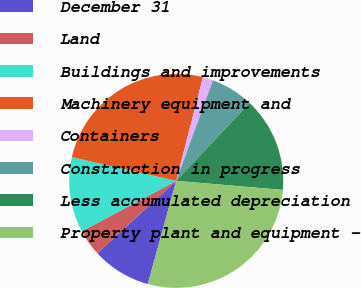<chart> <loc_0><loc_0><loc_500><loc_500><pie_chart><fcel>December 31<fcel>Land<fcel>Buildings and improvements<fcel>Machinery equipment and<fcel>Containers<fcel>Construction in progress<fcel>Less accumulated depreciation<fcel>Property plant and equipment -<nl><fcel>8.91%<fcel>4.01%<fcel>11.36%<fcel>25.47%<fcel>1.56%<fcel>6.46%<fcel>14.32%<fcel>27.92%<nl></chart> 